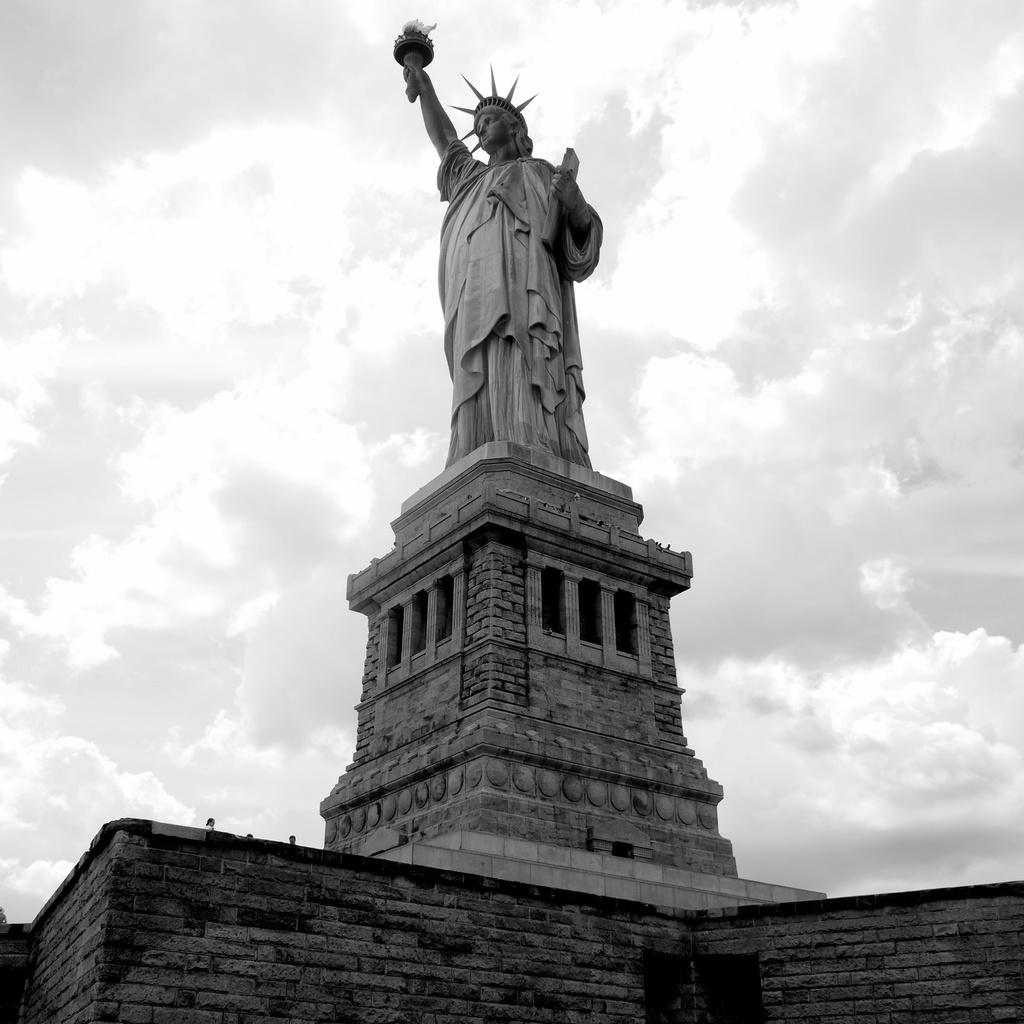What is the main subject in the center of the image? There is a statue in the center of the image. What is located at the bottom of the image? There is a wall at the bottom of the image. What can be seen at the top of the image? The sky is visible at the top of the image. What type of thumb is being used to sculpt the statue in the image? There is no thumb visible in the image, as it is a photograph of a completed statue. 